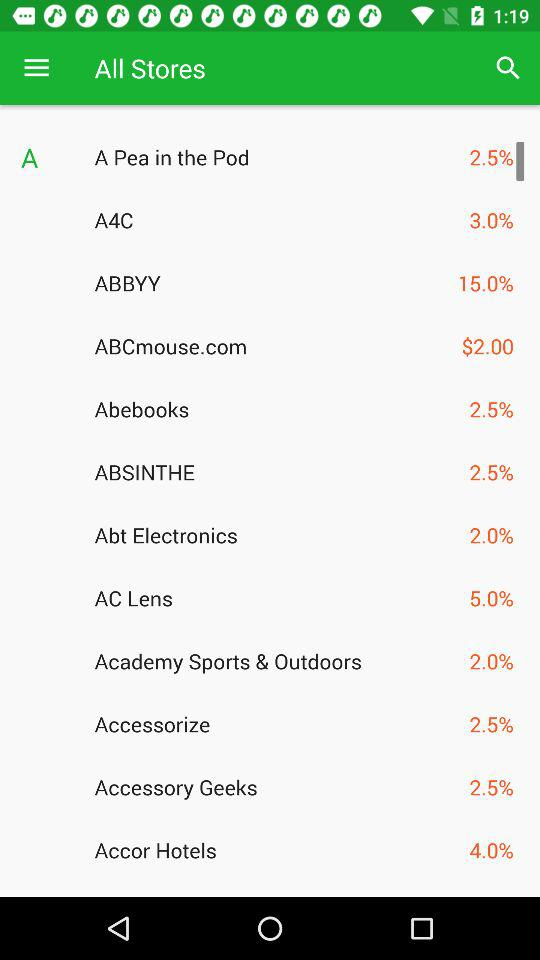What is the price shown for "ABCmouse.com"? The shown price is $2.00. 